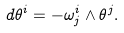Convert formula to latex. <formula><loc_0><loc_0><loc_500><loc_500>d \theta ^ { i } = - \omega ^ { i } _ { j } \wedge \theta ^ { j } .</formula> 